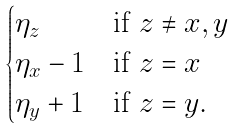<formula> <loc_0><loc_0><loc_500><loc_500>\begin{cases} \eta _ { z } & \text {if } z \neq x , y \\ \eta _ { x } - 1 & \text {if } z = x \\ \eta _ { y } + 1 & \text {if } z = y . \end{cases}</formula> 